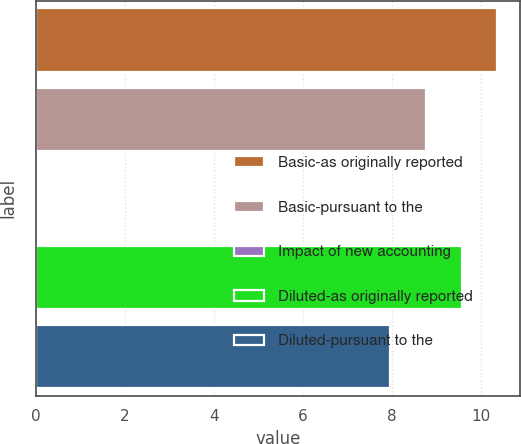Convert chart to OTSL. <chart><loc_0><loc_0><loc_500><loc_500><bar_chart><fcel>Basic-as originally reported<fcel>Basic-pursuant to the<fcel>Impact of new accounting<fcel>Diluted-as originally reported<fcel>Diluted-pursuant to the<nl><fcel>10.36<fcel>8.76<fcel>0.04<fcel>9.56<fcel>7.96<nl></chart> 